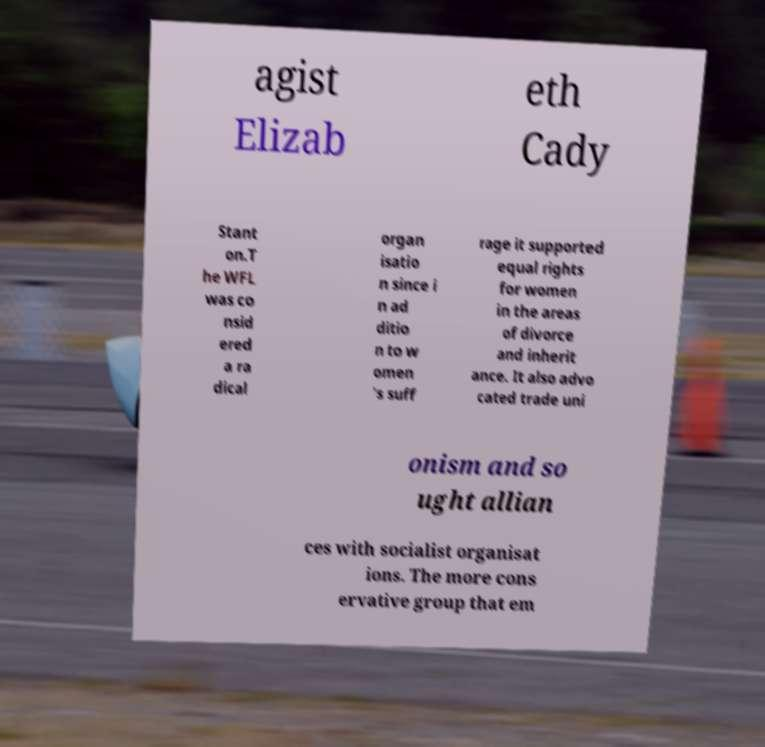I need the written content from this picture converted into text. Can you do that? agist Elizab eth Cady Stant on.T he WFL was co nsid ered a ra dical organ isatio n since i n ad ditio n to w omen 's suff rage it supported equal rights for women in the areas of divorce and inherit ance. It also advo cated trade uni onism and so ught allian ces with socialist organisat ions. The more cons ervative group that em 